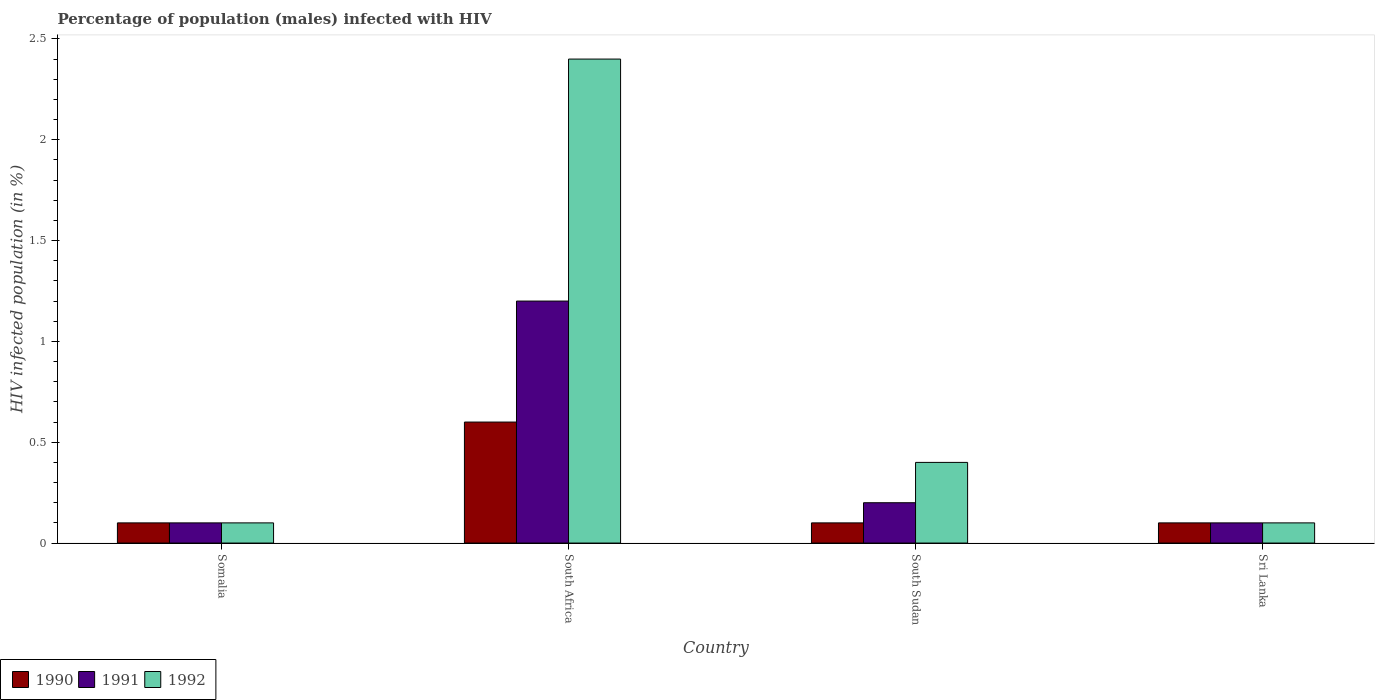How many different coloured bars are there?
Your answer should be very brief. 3. How many groups of bars are there?
Ensure brevity in your answer.  4. Are the number of bars per tick equal to the number of legend labels?
Offer a very short reply. Yes. How many bars are there on the 2nd tick from the left?
Make the answer very short. 3. How many bars are there on the 2nd tick from the right?
Keep it short and to the point. 3. What is the label of the 3rd group of bars from the left?
Keep it short and to the point. South Sudan. What is the percentage of HIV infected male population in 1992 in South Sudan?
Offer a terse response. 0.4. Across all countries, what is the maximum percentage of HIV infected male population in 1990?
Give a very brief answer. 0.6. Across all countries, what is the minimum percentage of HIV infected male population in 1992?
Your response must be concise. 0.1. In which country was the percentage of HIV infected male population in 1992 maximum?
Your response must be concise. South Africa. In which country was the percentage of HIV infected male population in 1992 minimum?
Give a very brief answer. Somalia. What is the difference between the percentage of HIV infected male population in 1992 in South Sudan and the percentage of HIV infected male population in 1990 in South Africa?
Keep it short and to the point. -0.2. What is the average percentage of HIV infected male population in 1990 per country?
Offer a terse response. 0.22. In how many countries, is the percentage of HIV infected male population in 1991 greater than 2.4 %?
Ensure brevity in your answer.  0. What is the ratio of the percentage of HIV infected male population in 1992 in South Africa to that in Sri Lanka?
Make the answer very short. 24. What is the difference between the highest and the second highest percentage of HIV infected male population in 1991?
Ensure brevity in your answer.  -1. What is the difference between the highest and the lowest percentage of HIV infected male population in 1991?
Offer a terse response. 1.1. In how many countries, is the percentage of HIV infected male population in 1991 greater than the average percentage of HIV infected male population in 1991 taken over all countries?
Your response must be concise. 1. What does the 3rd bar from the right in Somalia represents?
Provide a short and direct response. 1990. Is it the case that in every country, the sum of the percentage of HIV infected male population in 1990 and percentage of HIV infected male population in 1992 is greater than the percentage of HIV infected male population in 1991?
Keep it short and to the point. Yes. How many bars are there?
Provide a succinct answer. 12. Are all the bars in the graph horizontal?
Your answer should be very brief. No. What is the difference between two consecutive major ticks on the Y-axis?
Your answer should be compact. 0.5. Are the values on the major ticks of Y-axis written in scientific E-notation?
Make the answer very short. No. How many legend labels are there?
Make the answer very short. 3. What is the title of the graph?
Make the answer very short. Percentage of population (males) infected with HIV. What is the label or title of the X-axis?
Provide a succinct answer. Country. What is the label or title of the Y-axis?
Your answer should be compact. HIV infected population (in %). What is the HIV infected population (in %) of 1990 in Somalia?
Your answer should be very brief. 0.1. What is the HIV infected population (in %) of 1991 in Somalia?
Provide a short and direct response. 0.1. What is the HIV infected population (in %) of 1991 in South Africa?
Your response must be concise. 1.2. What is the HIV infected population (in %) of 1992 in South Africa?
Provide a succinct answer. 2.4. What is the HIV infected population (in %) of 1992 in South Sudan?
Provide a succinct answer. 0.4. What is the HIV infected population (in %) in 1992 in Sri Lanka?
Offer a terse response. 0.1. Across all countries, what is the maximum HIV infected population (in %) in 1992?
Your answer should be compact. 2.4. Across all countries, what is the minimum HIV infected population (in %) in 1990?
Keep it short and to the point. 0.1. Across all countries, what is the minimum HIV infected population (in %) in 1991?
Offer a very short reply. 0.1. What is the total HIV infected population (in %) in 1990 in the graph?
Keep it short and to the point. 0.9. What is the total HIV infected population (in %) in 1992 in the graph?
Keep it short and to the point. 3. What is the difference between the HIV infected population (in %) in 1990 in Somalia and that in South Africa?
Ensure brevity in your answer.  -0.5. What is the difference between the HIV infected population (in %) in 1991 in Somalia and that in South Africa?
Keep it short and to the point. -1.1. What is the difference between the HIV infected population (in %) of 1991 in Somalia and that in South Sudan?
Keep it short and to the point. -0.1. What is the difference between the HIV infected population (in %) of 1992 in Somalia and that in South Sudan?
Your response must be concise. -0.3. What is the difference between the HIV infected population (in %) in 1990 in Somalia and that in Sri Lanka?
Offer a very short reply. 0. What is the difference between the HIV infected population (in %) of 1991 in Somalia and that in Sri Lanka?
Provide a short and direct response. 0. What is the difference between the HIV infected population (in %) in 1992 in South Africa and that in South Sudan?
Keep it short and to the point. 2. What is the difference between the HIV infected population (in %) in 1990 in South Africa and that in Sri Lanka?
Your answer should be compact. 0.5. What is the difference between the HIV infected population (in %) of 1991 in South Africa and that in Sri Lanka?
Your answer should be very brief. 1.1. What is the difference between the HIV infected population (in %) of 1992 in South Africa and that in Sri Lanka?
Offer a very short reply. 2.3. What is the difference between the HIV infected population (in %) of 1990 in Somalia and the HIV infected population (in %) of 1991 in South Africa?
Offer a very short reply. -1.1. What is the difference between the HIV infected population (in %) in 1991 in Somalia and the HIV infected population (in %) in 1992 in South Africa?
Your answer should be compact. -2.3. What is the difference between the HIV infected population (in %) of 1990 in Somalia and the HIV infected population (in %) of 1991 in South Sudan?
Provide a succinct answer. -0.1. What is the difference between the HIV infected population (in %) in 1990 in Somalia and the HIV infected population (in %) in 1992 in South Sudan?
Keep it short and to the point. -0.3. What is the difference between the HIV infected population (in %) of 1991 in Somalia and the HIV infected population (in %) of 1992 in South Sudan?
Provide a short and direct response. -0.3. What is the difference between the HIV infected population (in %) of 1990 in Somalia and the HIV infected population (in %) of 1992 in Sri Lanka?
Your answer should be compact. 0. What is the difference between the HIV infected population (in %) in 1991 in South Africa and the HIV infected population (in %) in 1992 in Sri Lanka?
Offer a very short reply. 1.1. What is the difference between the HIV infected population (in %) of 1990 in South Sudan and the HIV infected population (in %) of 1991 in Sri Lanka?
Keep it short and to the point. 0. What is the difference between the HIV infected population (in %) in 1991 in South Sudan and the HIV infected population (in %) in 1992 in Sri Lanka?
Your answer should be very brief. 0.1. What is the average HIV infected population (in %) of 1990 per country?
Provide a succinct answer. 0.23. What is the average HIV infected population (in %) of 1991 per country?
Ensure brevity in your answer.  0.4. What is the difference between the HIV infected population (in %) in 1990 and HIV infected population (in %) in 1991 in Somalia?
Keep it short and to the point. 0. What is the difference between the HIV infected population (in %) in 1991 and HIV infected population (in %) in 1992 in South Africa?
Your response must be concise. -1.2. What is the difference between the HIV infected population (in %) of 1991 and HIV infected population (in %) of 1992 in Sri Lanka?
Your response must be concise. 0. What is the ratio of the HIV infected population (in %) of 1991 in Somalia to that in South Africa?
Your response must be concise. 0.08. What is the ratio of the HIV infected population (in %) of 1992 in Somalia to that in South Africa?
Provide a succinct answer. 0.04. What is the ratio of the HIV infected population (in %) of 1991 in Somalia to that in South Sudan?
Your answer should be compact. 0.5. What is the ratio of the HIV infected population (in %) of 1990 in Somalia to that in Sri Lanka?
Your answer should be very brief. 1. What is the ratio of the HIV infected population (in %) in 1992 in Somalia to that in Sri Lanka?
Your response must be concise. 1. What is the ratio of the HIV infected population (in %) of 1991 in South Africa to that in South Sudan?
Your answer should be very brief. 6. What is the ratio of the HIV infected population (in %) in 1992 in South Africa to that in South Sudan?
Offer a very short reply. 6. What is the difference between the highest and the second highest HIV infected population (in %) in 1990?
Give a very brief answer. 0.5. What is the difference between the highest and the second highest HIV infected population (in %) in 1991?
Make the answer very short. 1. What is the difference between the highest and the lowest HIV infected population (in %) in 1992?
Ensure brevity in your answer.  2.3. 